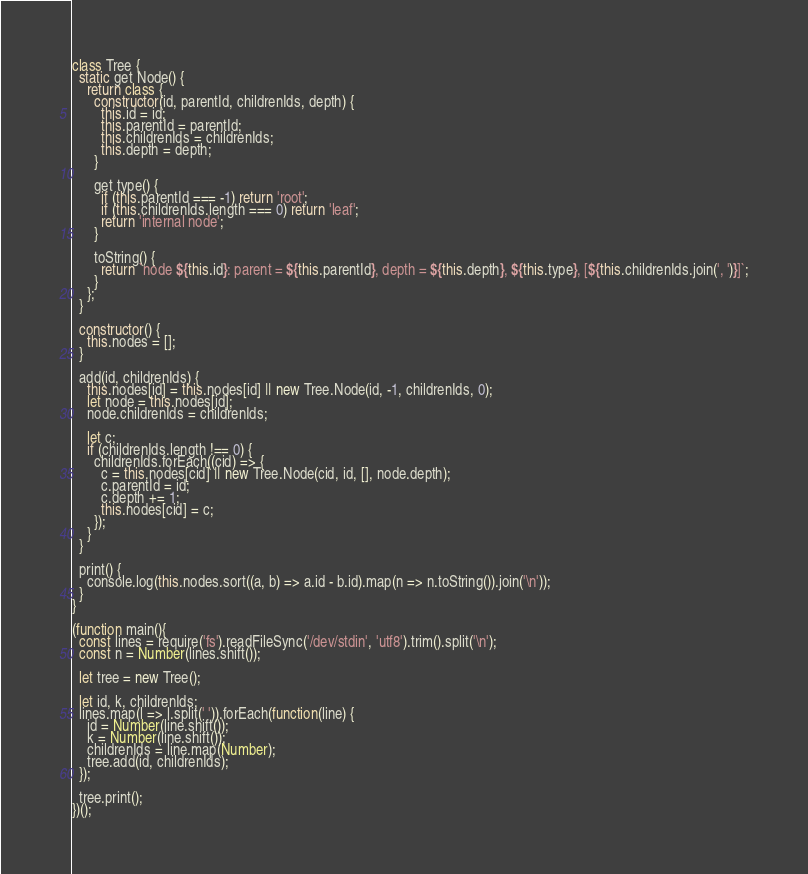<code> <loc_0><loc_0><loc_500><loc_500><_JavaScript_>class Tree {
  static get Node() {
    return class {
      constructor(id, parentId, childrenIds, depth) {
        this.id = id;
        this.parentId = parentId;
        this.childrenIds = childrenIds;
        this.depth = depth;
      }

      get type() {
        if (this.parentId === -1) return 'root';
        if (this.childrenIds.length === 0) return 'leaf';
        return 'internal node';
      }

      toString() {
        return `node ${this.id}: parent = ${this.parentId}, depth = ${this.depth}, ${this.type}, [${this.childrenIds.join(', ')}]`;
      }
    };
  }

  constructor() {
    this.nodes = [];
  }

  add(id, childrenIds) {
    this.nodes[id] = this.nodes[id] || new Tree.Node(id, -1, childrenIds, 0);
    let node = this.nodes[id];
    node.childrenIds = childrenIds;

    let c;
    if (childrenIds.length !== 0) {
      childrenIds.forEach((cid) => {
        c = this.nodes[cid] || new Tree.Node(cid, id, [], node.depth);
        c.parentId = id;
        c.depth += 1;
        this.nodes[cid] = c;
      });
    }
  }

  print() {
    console.log(this.nodes.sort((a, b) => a.id - b.id).map(n => n.toString()).join('\n'));
  }
}

(function main(){
  const lines = require('fs').readFileSync('/dev/stdin', 'utf8').trim().split('\n');
  const n = Number(lines.shift());

  let tree = new Tree();

  let id, k, childrenIds;
  lines.map(l => l.split(' ')).forEach(function(line) {
    id = Number(line.shift());
    k = Number(line.shift());
    childrenIds = line.map(Number);
    tree.add(id, childrenIds);
  });

  tree.print();
})();

</code> 